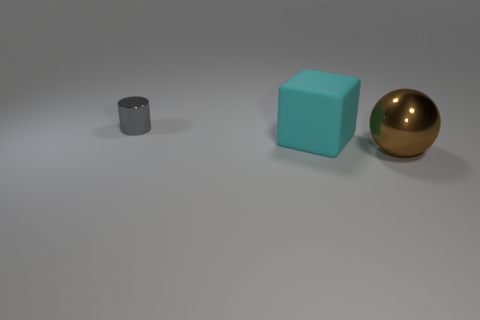Is the object in front of the large cyan object made of the same material as the small object?
Ensure brevity in your answer.  Yes. How many things are cylinders or metallic things to the left of the big cyan cube?
Provide a short and direct response. 1. There is a metallic thing that is behind the metal thing that is to the right of the gray shiny cylinder; what number of cyan blocks are to the left of it?
Provide a succinct answer. 0. There is a object in front of the large cyan cube; is it the same shape as the gray shiny thing?
Provide a short and direct response. No. Is there a shiny ball behind the metal thing that is in front of the tiny gray shiny cylinder?
Your answer should be very brief. No. What number of big purple metal cylinders are there?
Your response must be concise. 0. There is a object that is on the left side of the metal sphere and to the right of the small metal cylinder; what is its color?
Make the answer very short. Cyan. How many other rubber cubes have the same size as the block?
Your answer should be very brief. 0. What is the tiny cylinder made of?
Make the answer very short. Metal. There is a big cyan matte thing; are there any gray cylinders in front of it?
Offer a very short reply. No. 